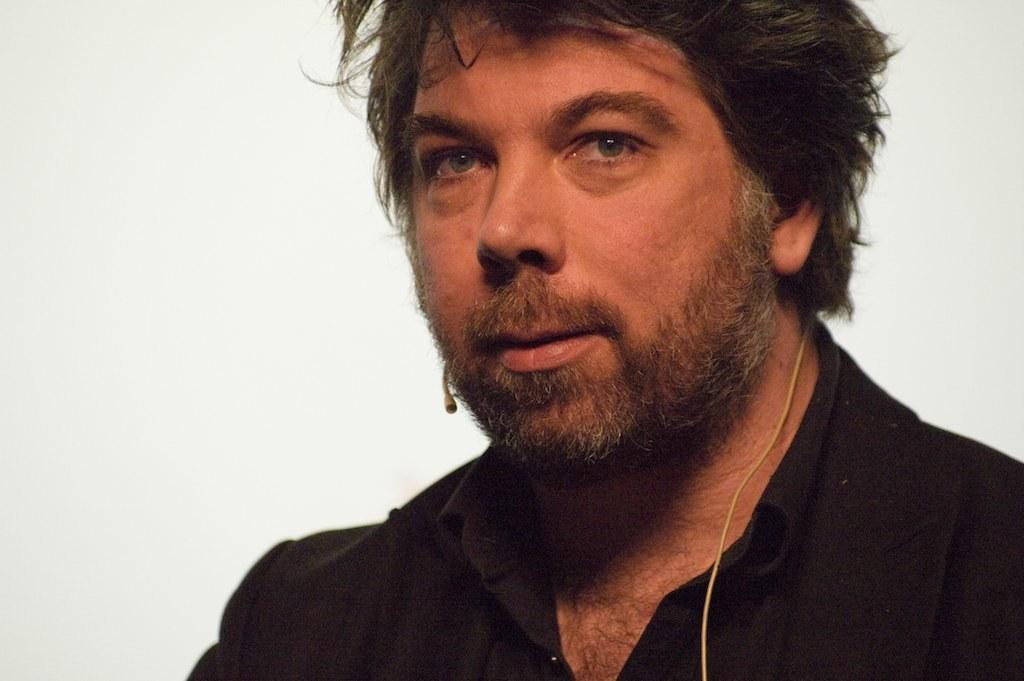Could you give a brief overview of what you see in this image? In the image we can see there is a man wearing black colour shirt and there is a mic attached to his ears. 